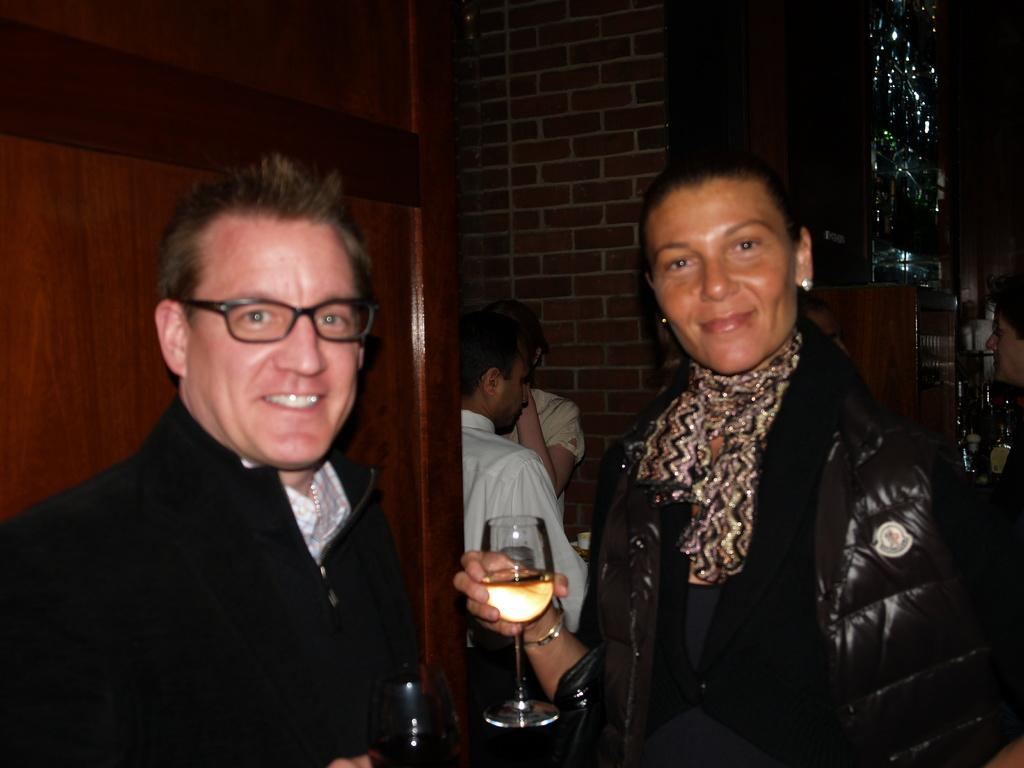How many people are visible in the image? There are two persons standing in the image. What are the two persons holding in their hands? The two persons are holding a wine glass in their hand. Are there any other people visible in the image? Yes, there are two people standing in the background. What type of paste is being used to move the people in the image? There is no paste or movement of people in the image; it shows two persons standing and holding wine glasses. 